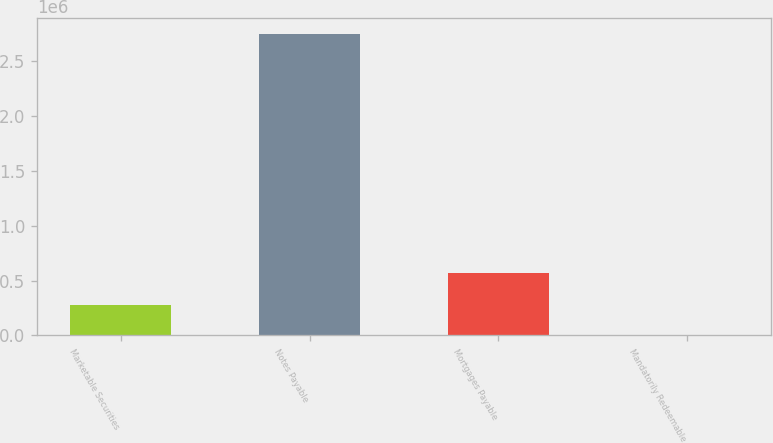<chart> <loc_0><loc_0><loc_500><loc_500><bar_chart><fcel>Marketable Securities<fcel>Notes Payable<fcel>Mortgages Payable<fcel>Mandatorily Redeemable<nl><fcel>275971<fcel>2.74834e+06<fcel>567917<fcel>1263<nl></chart> 